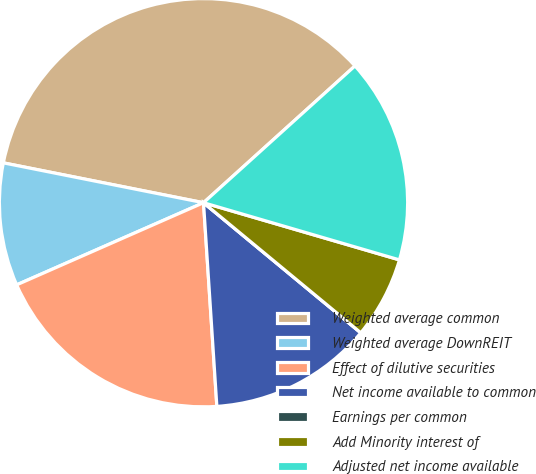Convert chart. <chart><loc_0><loc_0><loc_500><loc_500><pie_chart><fcel>Weighted average common<fcel>Weighted average DownREIT<fcel>Effect of dilutive securities<fcel>Net income available to common<fcel>Earnings per common<fcel>Add Minority interest of<fcel>Adjusted net income available<nl><fcel>35.18%<fcel>9.72%<fcel>19.45%<fcel>12.96%<fcel>0.0%<fcel>6.48%<fcel>16.21%<nl></chart> 